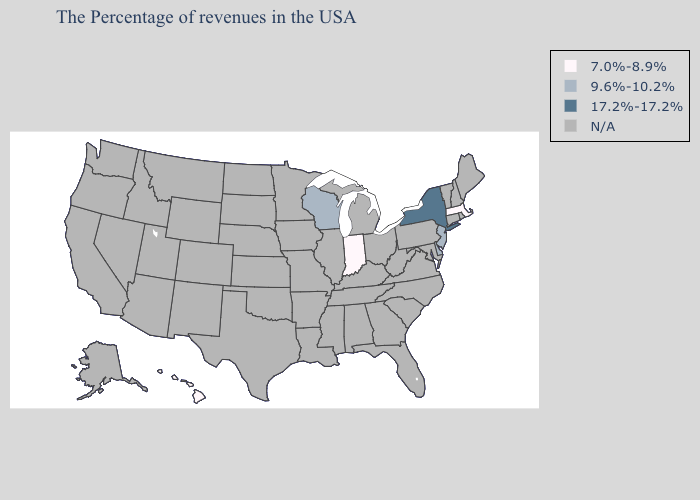Name the states that have a value in the range 9.6%-10.2%?
Write a very short answer. New Jersey, Delaware, Wisconsin. What is the highest value in the South ?
Give a very brief answer. 9.6%-10.2%. What is the highest value in the West ?
Concise answer only. 7.0%-8.9%. What is the value of Pennsylvania?
Give a very brief answer. N/A. Which states have the lowest value in the South?
Short answer required. Delaware. Among the states that border Rhode Island , which have the highest value?
Answer briefly. Massachusetts. What is the value of Alaska?
Keep it brief. N/A. What is the value of Indiana?
Quick response, please. 7.0%-8.9%. 